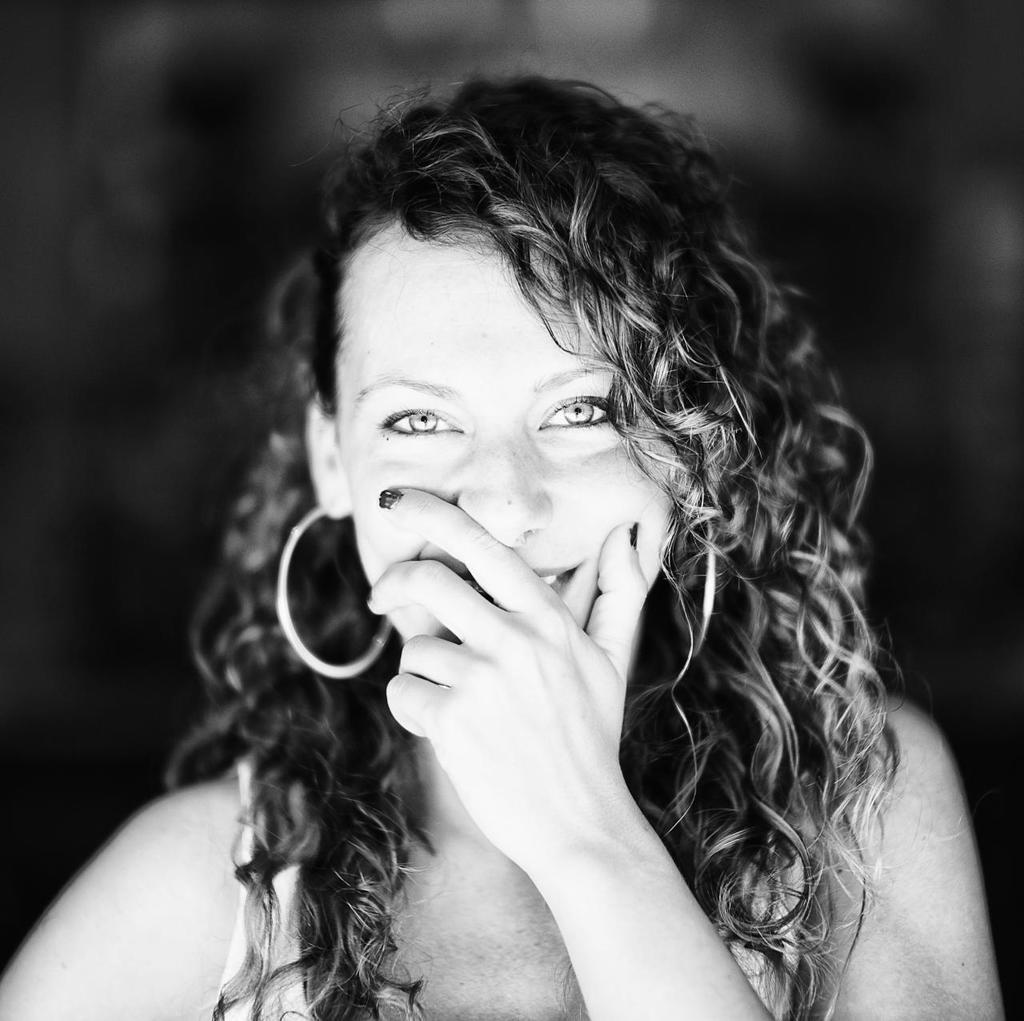Who is the main subject in the image? There is a woman in the image. What can be observed about the background of the image? The background of the image is blurred. What type of paper is the fireman holding in the image? There is no fireman or paper present in the image; it only features a woman. 